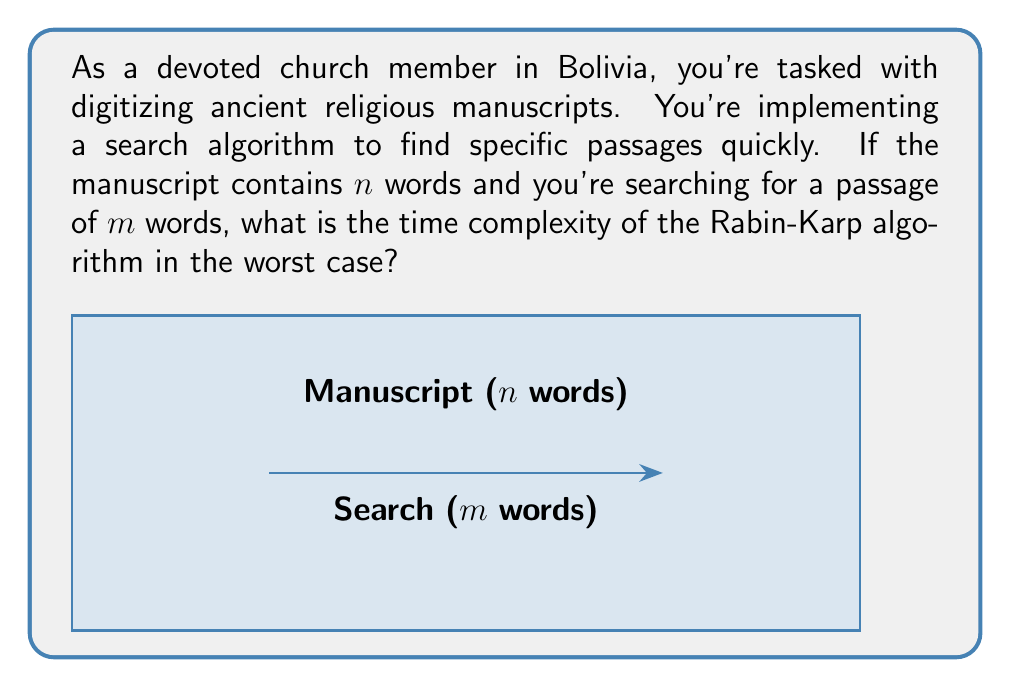Could you help me with this problem? Let's analyze the Rabin-Karp algorithm step-by-step:

1) The Rabin-Karp algorithm uses a rolling hash function to compare the hash value of the pattern with the hash values of substrings of the text.

2) Initial computation:
   - Calculate the hash value of the pattern (passage): $O(m)$
   - Calculate the hash value of the first $m$ words in the text: $O(m)$

3) For each subsequent position in the text:
   - Update the rolling hash in constant time: $O(1)$
   - Compare the hash values: $O(1)$
   - If hash values match, compare the actual substrings: $O(m)$ in worst case

4) The algorithm slides the pattern $n-m+1$ times over the text.

5) In the worst case, every hash comparison leads to a full string comparison:
   $$(n-m+1) \cdot O(m) = O((n-m+1)m)$$

6) Simplifying:
   - If $m$ is significantly smaller than $n$, this is approximately $O(nm)$
   - In the worst case where $m$ is close to $n$, it's $O(n^2)$

Therefore, the worst-case time complexity of the Rabin-Karp algorithm is $O(nm)$.
Answer: $O(nm)$ 